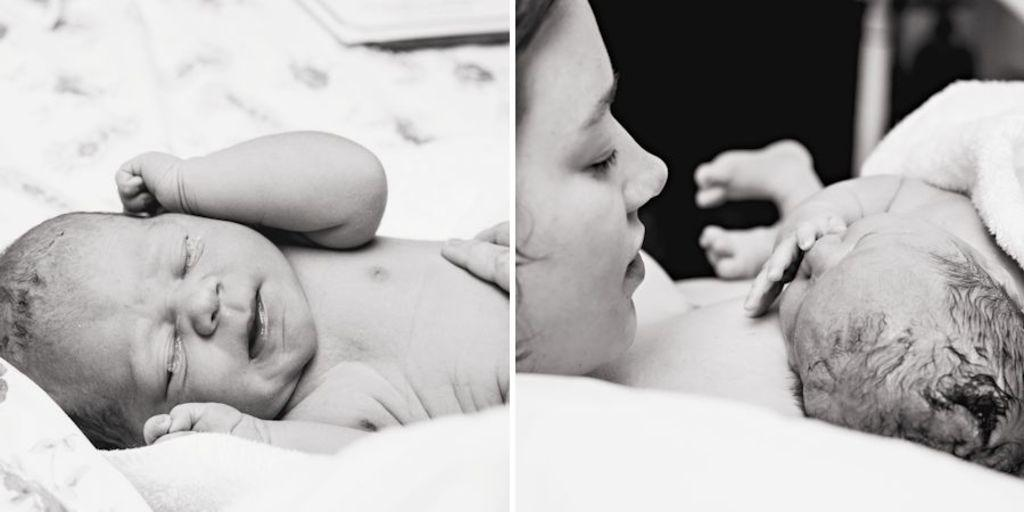What type of artwork is shown in the image? The image is a collage of multiple pictures. What can be seen in the first picture of the collage? In the first picture, there is a baby and a human hand. What is happening in the second picture of the collage? In the second picture, there is a woman holding a baby. What type of basket is being used by the woman in the image? There is no basket present in the image; the woman is simply holding the baby. Can you tell me how many volleyballs are visible in the image? There are no volleyballs present in the image. 